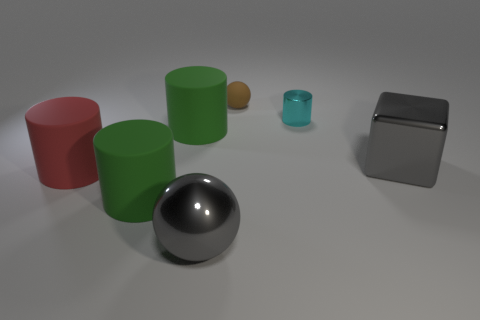Do the small rubber thing and the big shiny ball have the same color?
Provide a short and direct response. No. Are there fewer big gray objects that are behind the large metal sphere than metal things?
Your answer should be compact. Yes. Do the sphere that is in front of the small rubber thing and the brown sphere have the same material?
Your answer should be very brief. No. There is a large gray object on the right side of the matte thing that is to the right of the big gray object that is left of the tiny brown ball; what shape is it?
Offer a terse response. Cube. Is there a gray block of the same size as the metal cylinder?
Provide a succinct answer. No. How big is the metallic cylinder?
Keep it short and to the point. Small. What number of green things have the same size as the gray cube?
Provide a short and direct response. 2. Are there fewer large cylinders behind the cube than big cubes in front of the shiny cylinder?
Ensure brevity in your answer.  No. There is a gray thing to the right of the shiny thing left of the sphere that is behind the red matte cylinder; how big is it?
Provide a succinct answer. Large. What is the size of the object that is left of the small brown matte ball and behind the gray block?
Your answer should be very brief. Large. 